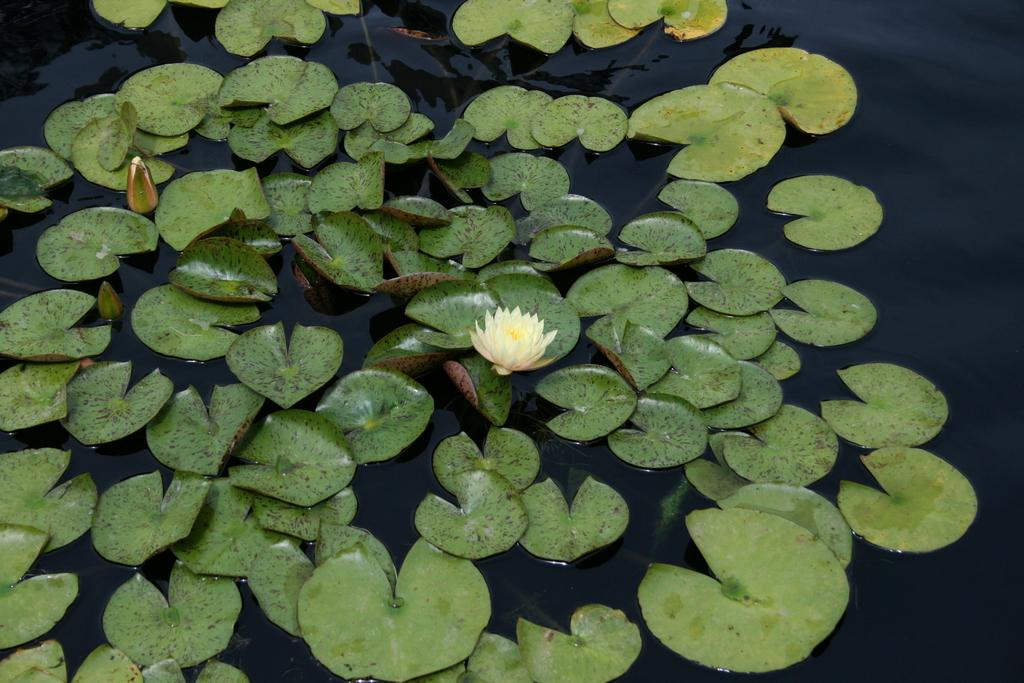What is the main subject of the image? There is a flower in the image. What is the flower resting on? The flower is on leaves. What else can be seen in the background of the image? There are leaves visible in the background of the image. What is the location of the leaves in the background? The leaves in the background are on water. How many tomatoes are floating in the water in the image? There are no tomatoes present in the image. What type of metal is visible in the image? There is no metal, such as zinc, visible in the image. 